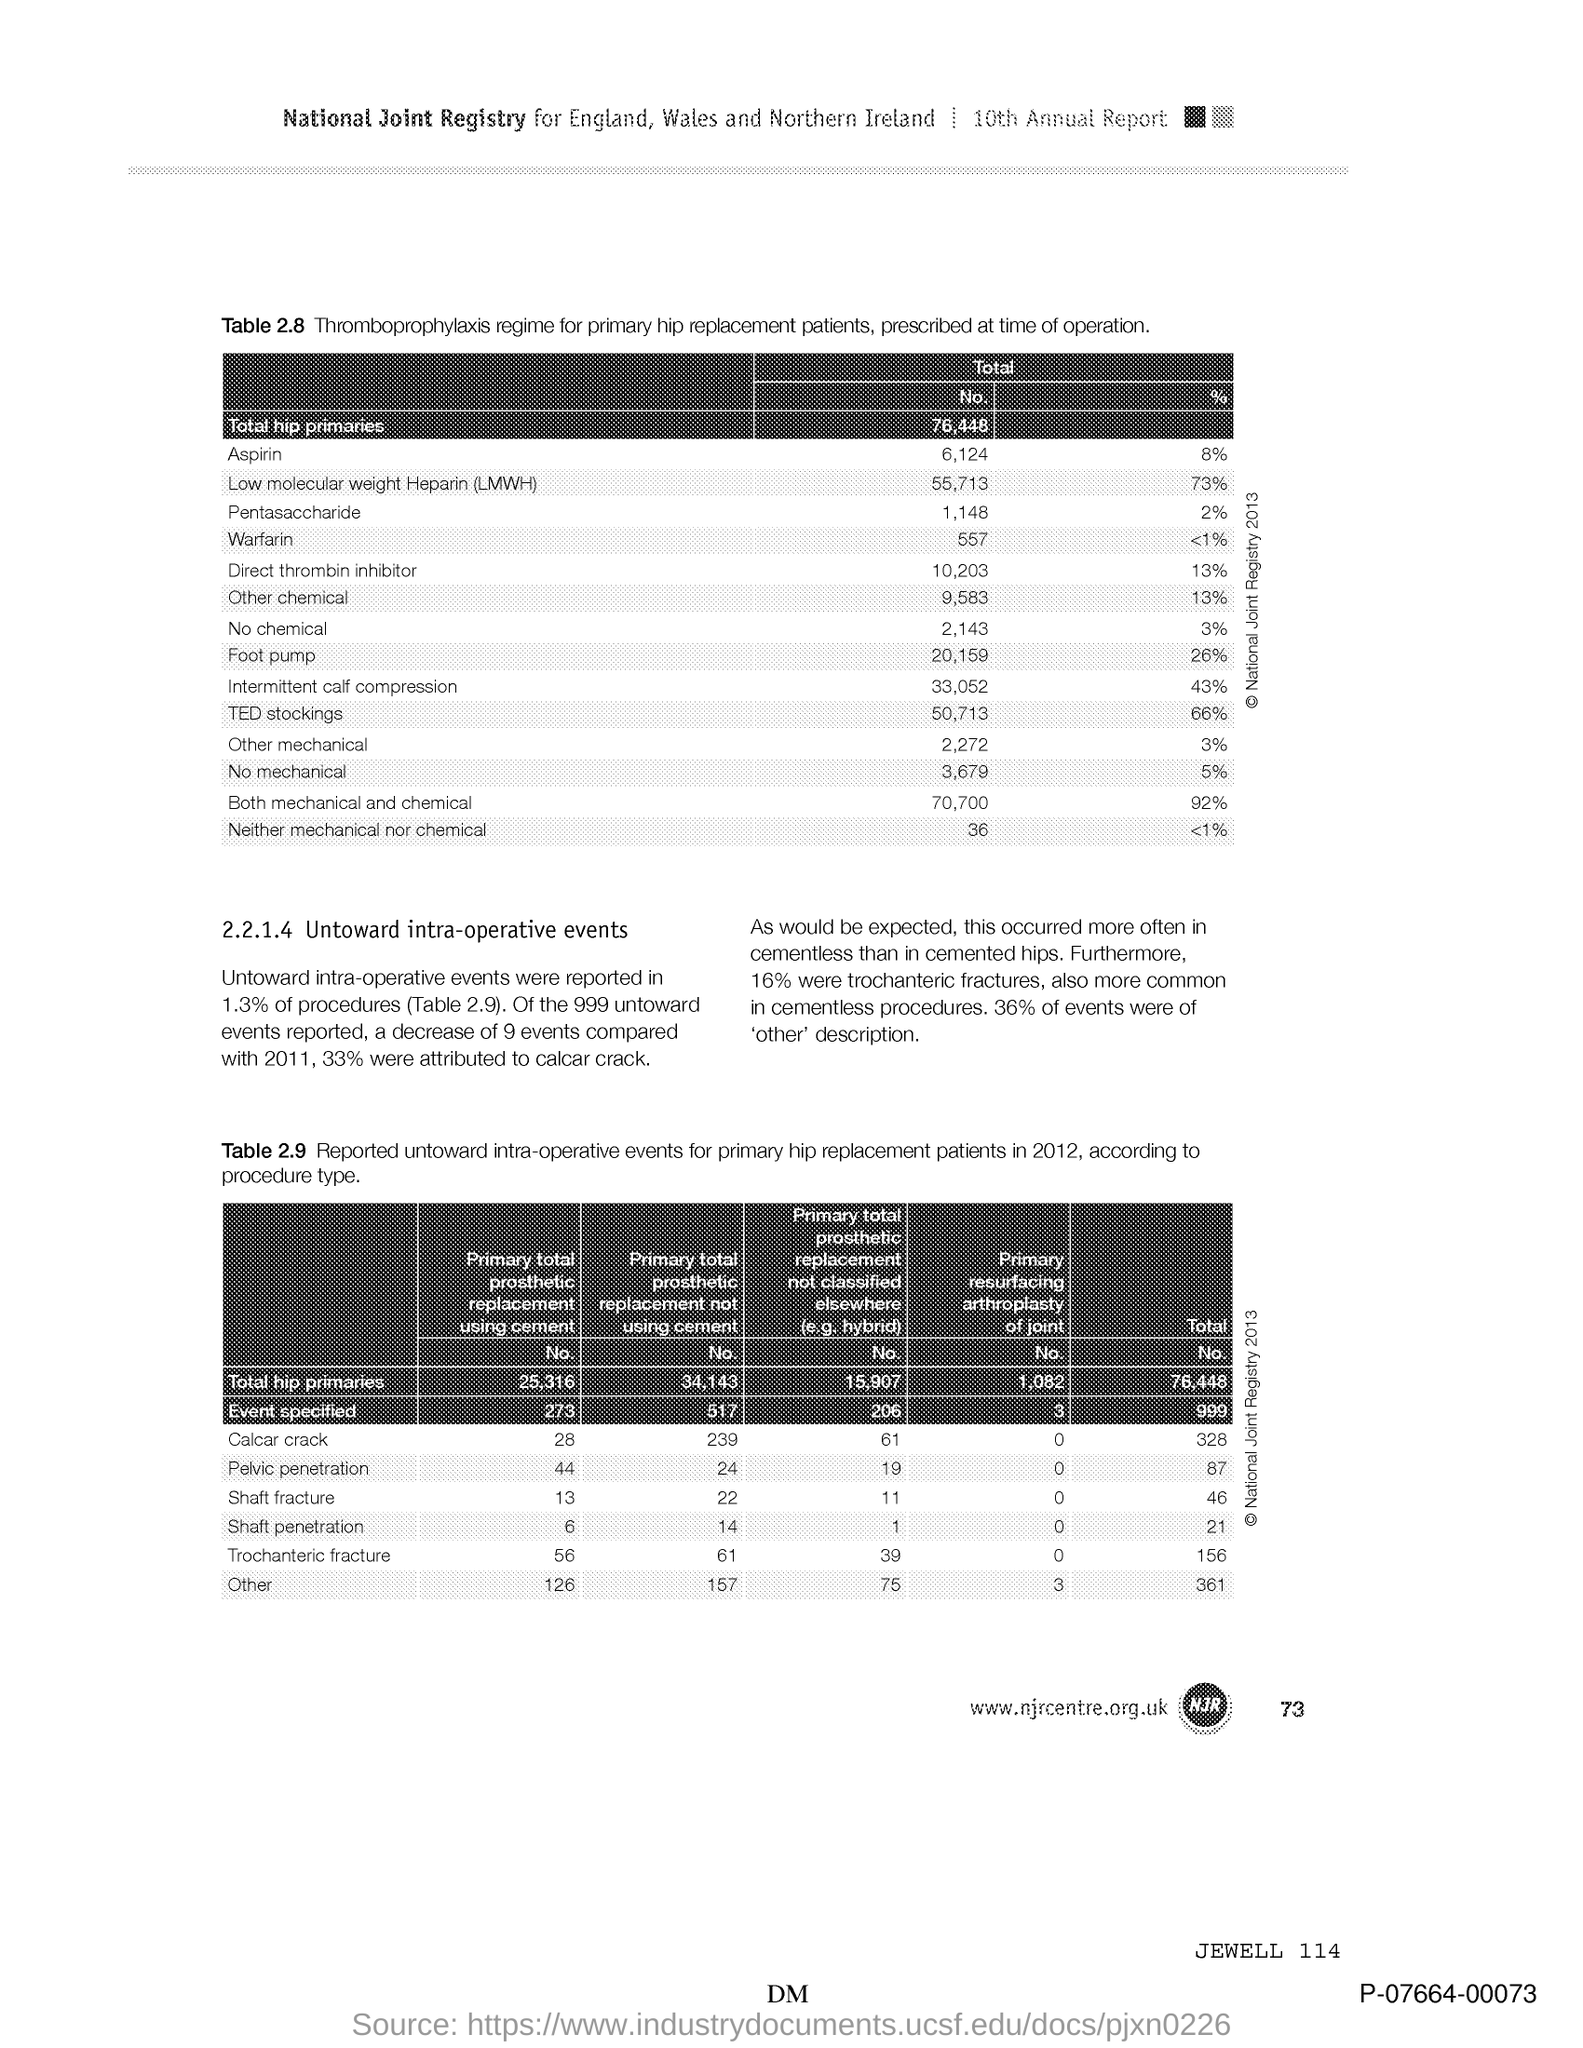Mention a couple of crucial points in this snapshot. The document mentions the 10th edition of the Annual Report. According to our analysis, there were a total of 76,448 hip primaries. 